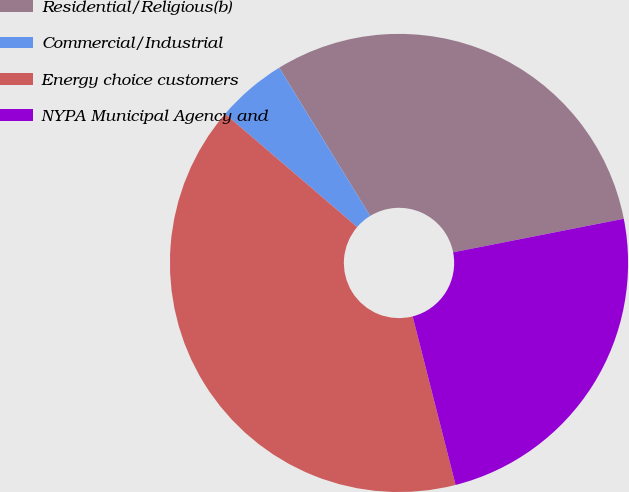Convert chart. <chart><loc_0><loc_0><loc_500><loc_500><pie_chart><fcel>Residential/Religious(b)<fcel>Commercial/Industrial<fcel>Energy choice customers<fcel>NYPA Municipal Agency and<nl><fcel>30.67%<fcel>4.96%<fcel>40.25%<fcel>24.12%<nl></chart> 